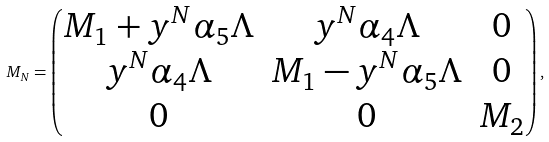Convert formula to latex. <formula><loc_0><loc_0><loc_500><loc_500>M _ { N } = \begin{pmatrix} M _ { 1 } + y ^ { N } \alpha _ { 5 } \Lambda & y ^ { N } \alpha _ { 4 } \Lambda & 0 \\ y ^ { N } \alpha _ { 4 } \Lambda & M _ { 1 } - y ^ { N } \alpha _ { 5 } \Lambda & 0 \\ 0 & 0 & M _ { 2 } \end{pmatrix} ,</formula> 